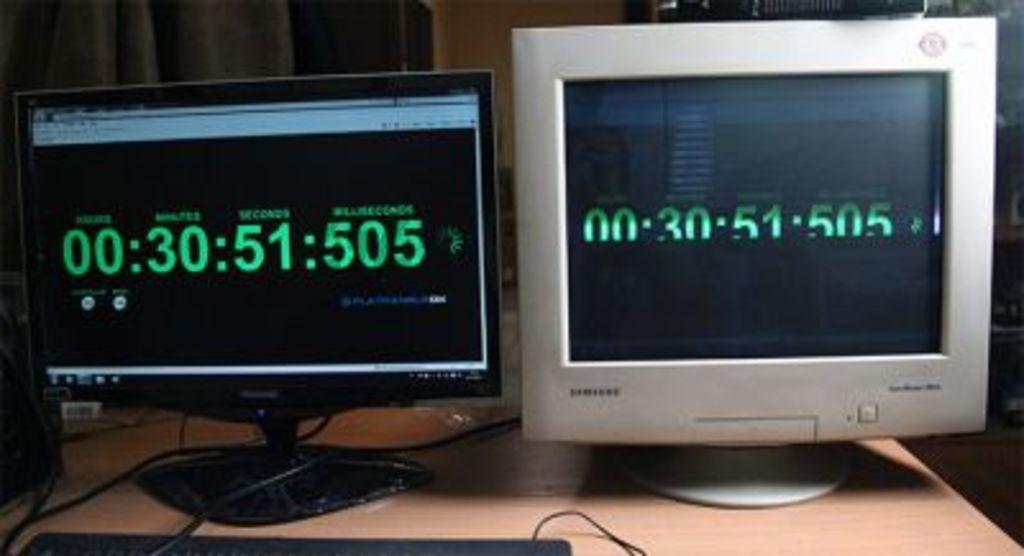What is the furthermost left number?
Provide a short and direct response. 0. 